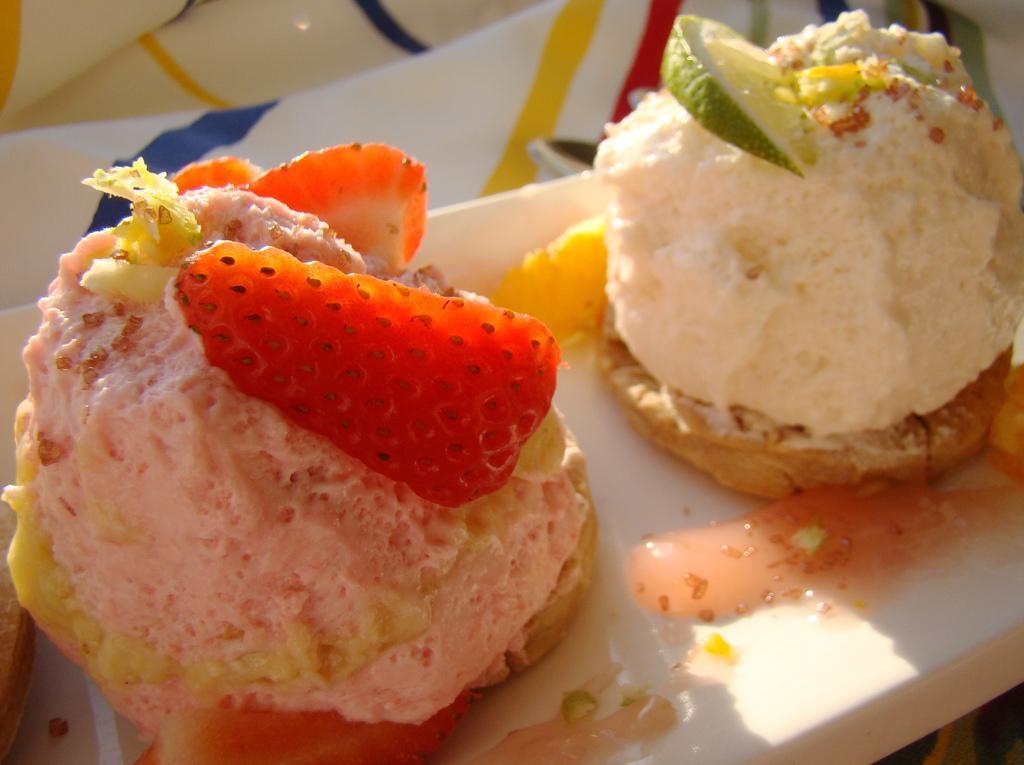Could you give a brief overview of what you see in this image? In this picture we can see food. 